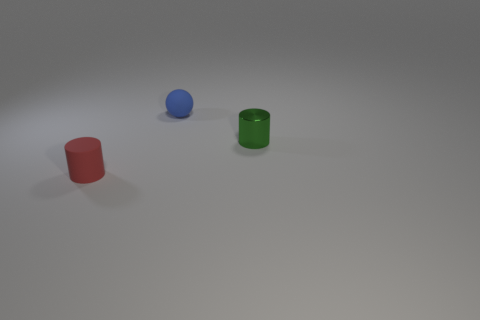What can you infer about the surface the objects are placed on? The surface appears to be a flat, featureless plane with a smooth texture, suggesting an indoor setting with artificial lighting. 